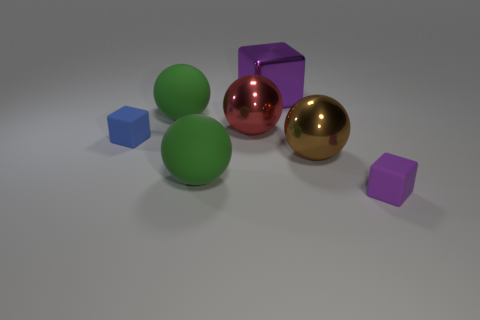Add 2 tiny brown metal cylinders. How many objects exist? 9 Subtract all cubes. How many objects are left? 4 Subtract all green balls. Subtract all yellow blocks. How many balls are left? 2 Subtract all brown balls. How many purple cubes are left? 2 Subtract all small purple blocks. Subtract all shiny spheres. How many objects are left? 4 Add 1 tiny matte objects. How many tiny matte objects are left? 3 Add 6 tiny shiny blocks. How many tiny shiny blocks exist? 6 Subtract all purple cubes. How many cubes are left? 1 Subtract all matte blocks. How many blocks are left? 1 Subtract 0 gray cubes. How many objects are left? 7 